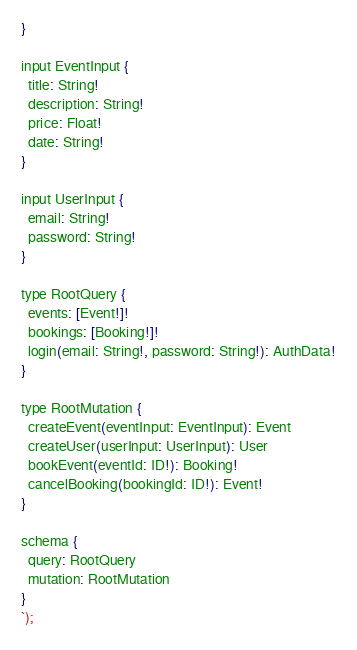Convert code to text. <code><loc_0><loc_0><loc_500><loc_500><_JavaScript_>}

input EventInput {
  title: String!
  description: String!
  price: Float!
  date: String!
}

input UserInput {
  email: String!
  password: String!
}

type RootQuery {
  events: [Event!]!
  bookings: [Booking!]!
  login(email: String!, password: String!): AuthData!
}

type RootMutation {
  createEvent(eventInput: EventInput): Event
  createUser(userInput: UserInput): User
  bookEvent(eventId: ID!): Booking!
  cancelBooking(bookingId: ID!): Event!
}

schema {
  query: RootQuery
  mutation: RootMutation
}
`);</code> 